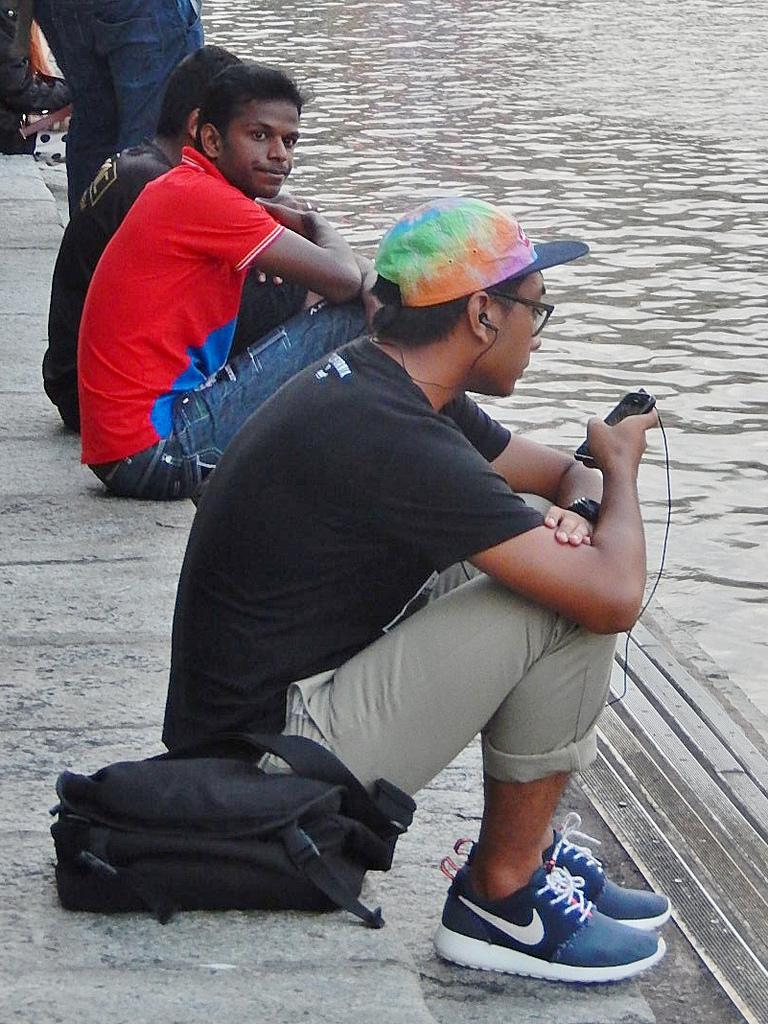Question: what are the boys doing?
Choices:
A. Sitting by a lake.
B. Sitting by a park bench.
C. Sitting by the ocean.
D. Sitting by a pond.
Answer with the letter. Answer: A Question: what is the boy to the right doing?
Choices:
A. Listening to a lecture.
B. Listening to music.
C. Listening to a movie.
D. Listening to a podcast.
Answer with the letter. Answer: B Question: why is the boy in red looking away?
Choices:
A. The sign.
B. The flyer.
C. He's distracted.
D. The poster.
Answer with the letter. Answer: C Question: who is next to the boy in red?
Choices:
A. A boy in blue.
B. A boy in black.
C. A boy in pink.
D. A boy in yellow.
Answer with the letter. Answer: B Question: what is in the boy's hand?
Choices:
A. A cell phone.
B. A game boy.
C. A banna.
D. A book.
Answer with the letter. Answer: A Question: when was this image most likely taken?
Choices:
A. During the day.
B. During the night.
C. During the afternoon.
D. During the morning.
Answer with the letter. Answer: A Question: who is sitting by the water?
Choices:
A. Men.
B. Birds.
C. Alligator.
D. Married couple.
Answer with the letter. Answer: A Question: who is listening to music?
Choices:
A. Girl in a jacket.
B. Lady wearing a sweater.
C. Choir member.
D. Man in hat.
Answer with the letter. Answer: D Question: who wears blue shoes?
Choices:
A. One man.
B. Clowns.
C. Children.
D. Women.
Answer with the letter. Answer: A Question: who wears a tie dye cap?
Choices:
A. One Woman.
B. One boy.
C. One man.
D. One girl.
Answer with the letter. Answer: C Question: who is watching guy with phone?
Choices:
A. Woman in blue blouse.
B. A young boy.
C. The director.
D. Man in red shirt.
Answer with the letter. Answer: D Question: what looks calm and dirty brown?
Choices:
A. Hot chocolate.
B. Water.
C. A fish pond.
D. My swimming pool.
Answer with the letter. Answer: B Question: where is the swoosh?
Choices:
A. In his hair cut.
B. On the man's shoe.
C. In the picture.
D. In the clouds.
Answer with the letter. Answer: B Question: who wears a red shirt?
Choices:
A. The baby.
B. A man.
C. The daughter.
D. The mother.
Answer with the letter. Answer: B Question: what brand of shoes is the front boy wearing?
Choices:
A. Reebok.
B. Adidas.
C. Converse.
D. Nike.
Answer with the letter. Answer: D Question: what color is the front boy's bag?
Choices:
A. Black.
B. White.
C. Red.
D. Yellow.
Answer with the letter. Answer: A Question: what color are the front boy's shoes?
Choices:
A. Black.
B. White.
C. Blue.
D. Brown.
Answer with the letter. Answer: C 